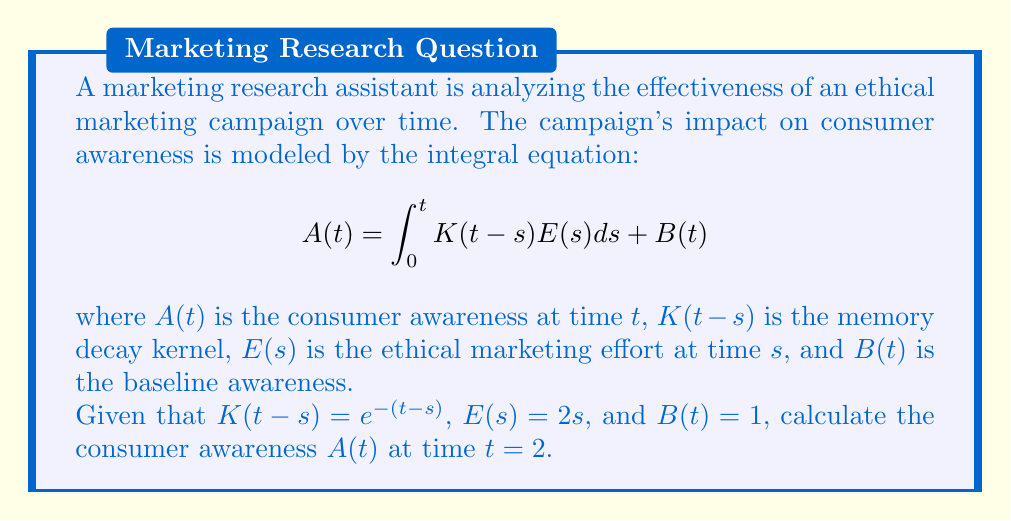What is the answer to this math problem? To solve this problem, we need to follow these steps:

1) First, we substitute the given functions into the integral equation:

   $$A(2) = \int_0^2 e^{-(2-s)}(2s)ds + 1$$

2) We can simplify the integrand:

   $$A(2) = 2\int_0^2 se^{-(2-s)}ds + 1$$

3) To solve this integral, we can use integration by parts. Let $u = s$ and $dv = e^{-(2-s)}ds$. Then $du = ds$ and $v = -e^{-(2-s)}$.

   $$A(2) = 2[-se^{-(2-s)}]_0^2 + 2\int_0^2 e^{-(2-s)}ds + 1$$

4) Evaluating the first term:

   $$A(2) = 2[-2e^0 - (-0e^{-2})] + 2\int_0^2 e^{-(2-s)}ds + 1$$
   $$A(2) = -4 + 2\int_0^2 e^{-(2-s)}ds + 1$$

5) Now we solve the remaining integral:

   $$2\int_0^2 e^{-(2-s)}ds = 2[-e^{-(2-s)}]_0^2 = 2[-1 - (-e^{-2})]$$

6) Simplifying:

   $$A(2) = -4 + 2[-1 + e^{-2}] + 1$$
   $$A(2) = -4 - 2 + 2e^{-2} + 1$$
   $$A(2) = 2e^{-2} - 5$$

7) Using a calculator to evaluate $e^{-2}$:

   $$A(2) = 2(0.1353) - 5 = 0.2706 - 5 = -4.7294$$

Therefore, the consumer awareness at time $t = 2$ is approximately -4.7294.
Answer: $-4.7294$ 